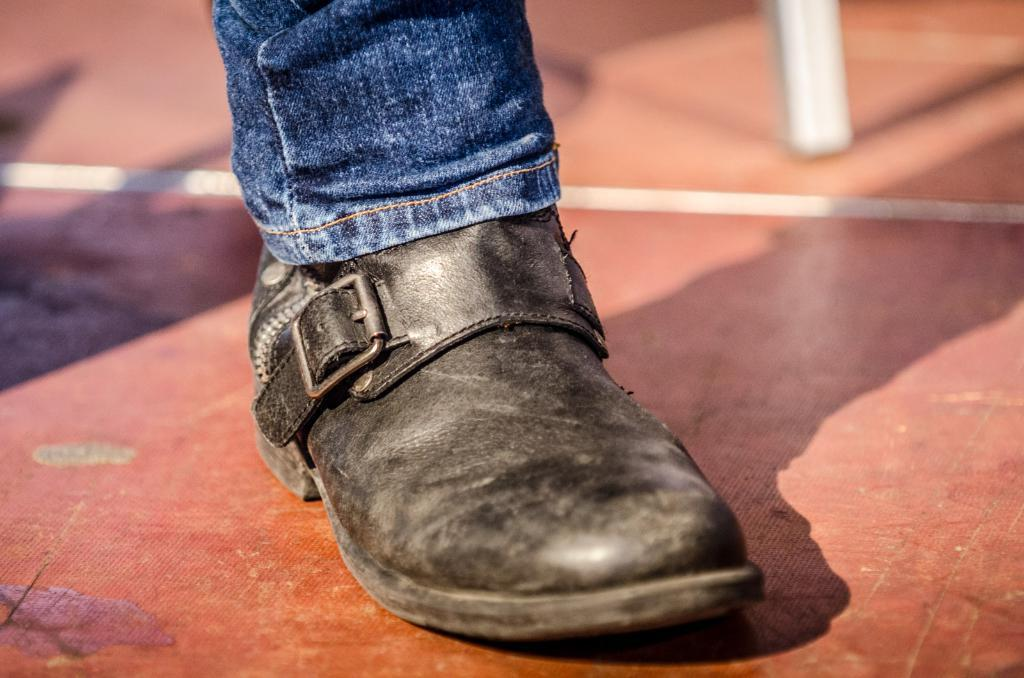What part of a person can be seen in the image? There is a leg of a person visible in the image. What is the person wearing on their leg? The person is wearing a shoe. Where are the leg and shoe located in the image? The leg and shoe are on the floor. What type of rail can be seen supporting the root in the image? There is no rail or root present in the image; it only features a leg and shoe on the floor. 